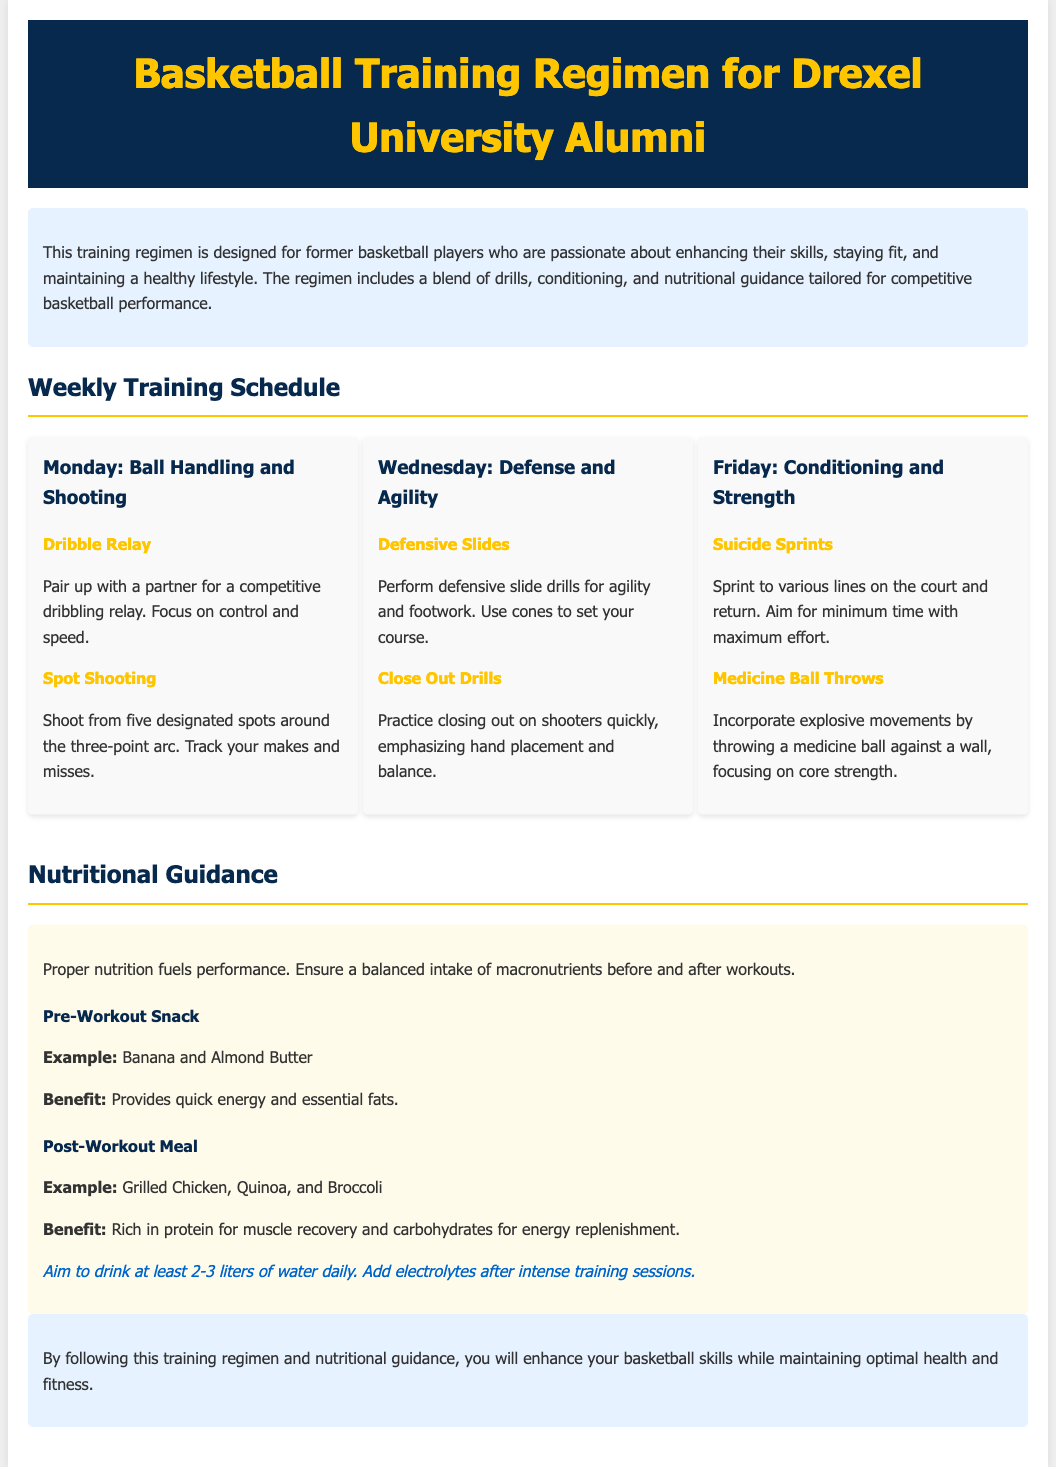what is the main focus of the training regimen? The training regimen is designed for former basketball players who are passionate about enhancing their skills, staying fit, and maintaining a healthy lifestyle.
Answer: enhancing skills which day is dedicated to defense and agility? The document outlines the training schedule and identifies specific days for each focus area. Defense and agility drills are scheduled for Wednesday.
Answer: Wednesday name a drill included on Monday's session. The document lists various drills for each day's training focus and identifies specific drills under each category. One drill on Monday is Dribble Relay.
Answer: Dribble Relay what is recommended as a pre-workout snack? The nutritional guidance section provides examples of meals and snacks to consume before and after workouts. A pre-workout snack example is Banana and Almond Butter.
Answer: Banana and Almond Butter how many liters of water should be consumed daily? The hydration guidance mentions a specific daily intake recommendation. Aim to drink at least 2-3 liters of water daily.
Answer: 2-3 liters 